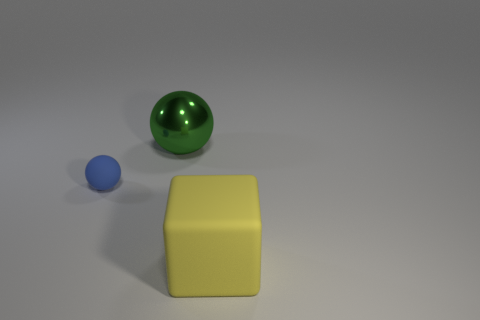Add 2 cyan things. How many objects exist? 5 Subtract all spheres. How many objects are left? 1 Subtract 0 purple cubes. How many objects are left? 3 Subtract all big cyan shiny spheres. Subtract all big green things. How many objects are left? 2 Add 3 tiny rubber things. How many tiny rubber things are left? 4 Add 3 large blocks. How many large blocks exist? 4 